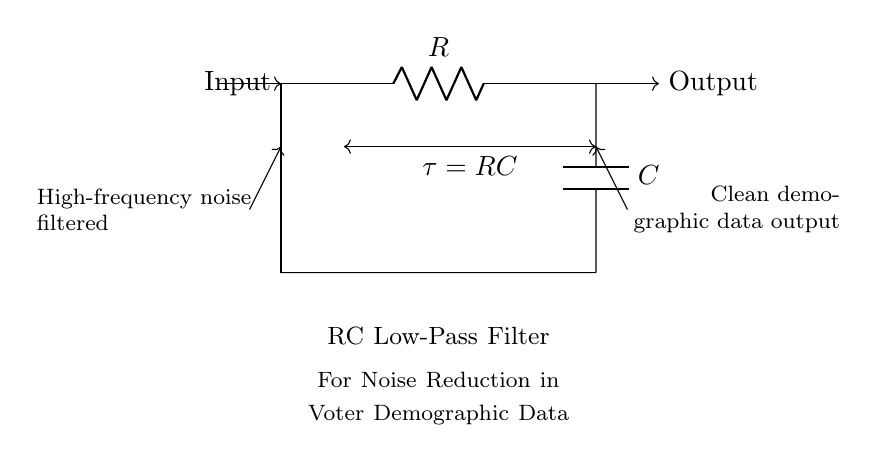What are the components used in the circuit? The circuit consists of a resistor (R) and a capacitor (C), which are the two essential components defining an RC low-pass filter.
Answer: Resistor, Capacitor What is the purpose of this RC low-pass filter? The purpose is to reduce high-frequency noise from the input signal, allowing only the low-frequency data to pass through for clean demographic data collection.
Answer: Noise reduction What does the symbol "τ" represent? The symbol "τ" represents the time constant of the RC circuit. It is calculated by multiplying the resistance value (R) with the capacitance value (C), indicating the speed of the circuit's response to changes in voltage.
Answer: RC How are the components connected in the circuit? The resistor is connected in series with the capacitor. The input signal is fed into the resistor, and the output is taken after the capacitor, which connects to ground. This series connection forms the low-pass filter.
Answer: Series connection What happens to high-frequency signals in this filter? High-frequency signals are attenuated by the capacitor, which prevents them from passing through to the output. As a result, these signals are filtered out, and only lower frequencies are allowed to reach the output.
Answer: Attenuated What is the relationship between R, C, and τ? The relationship is described by the equation τ = R * C, indicating how the resistor and capacitor values determine the time constant of the filter's response. A larger value of τ means a slower response and better filtering of noise.
Answer: τ = RC What does "clean demographic data output" refer to in this context? It refers to the resultant signal after the filtering process, which has been processed through the RC low-pass filter, indicating that high-frequency noise has been successfully removed, leaving behind the important demographic data.
Answer: Clean output 